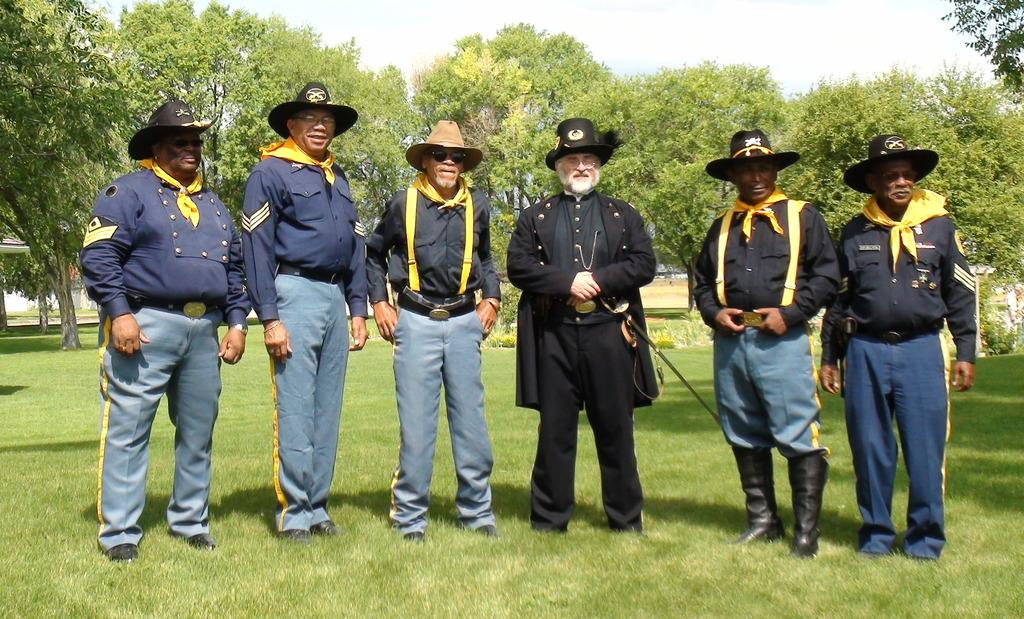How many people are in the image? There are persons standing in the image. What object can be seen in the image that is typically used for cutting? There is a knife in the image. What type of vegetation is present in the image? There are trees and grass in the image. What can be seen in the background of the image? There appears to be a building in the background of the image. What is visible at the top of the image? The sky is visible at the top of the image. Can you tell me the price of the item on the top of the image? There is no item with a price or receipt present in the image; it features persons standing, a knife, trees, grass, a building, and the sky. 